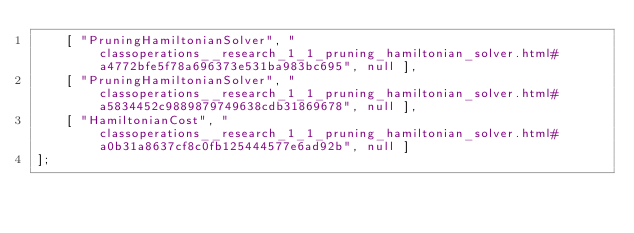<code> <loc_0><loc_0><loc_500><loc_500><_JavaScript_>    [ "PruningHamiltonianSolver", "classoperations__research_1_1_pruning_hamiltonian_solver.html#a4772bfe5f78a696373e531ba983bc695", null ],
    [ "PruningHamiltonianSolver", "classoperations__research_1_1_pruning_hamiltonian_solver.html#a5834452c9889879749638cdb31869678", null ],
    [ "HamiltonianCost", "classoperations__research_1_1_pruning_hamiltonian_solver.html#a0b31a8637cf8c0fb125444577e6ad92b", null ]
];</code> 